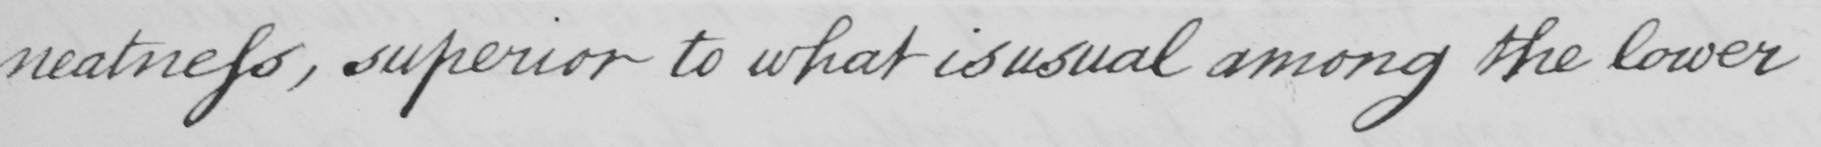What does this handwritten line say? neatness, superior to what is usual among the lower 